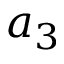<formula> <loc_0><loc_0><loc_500><loc_500>a _ { 3 }</formula> 